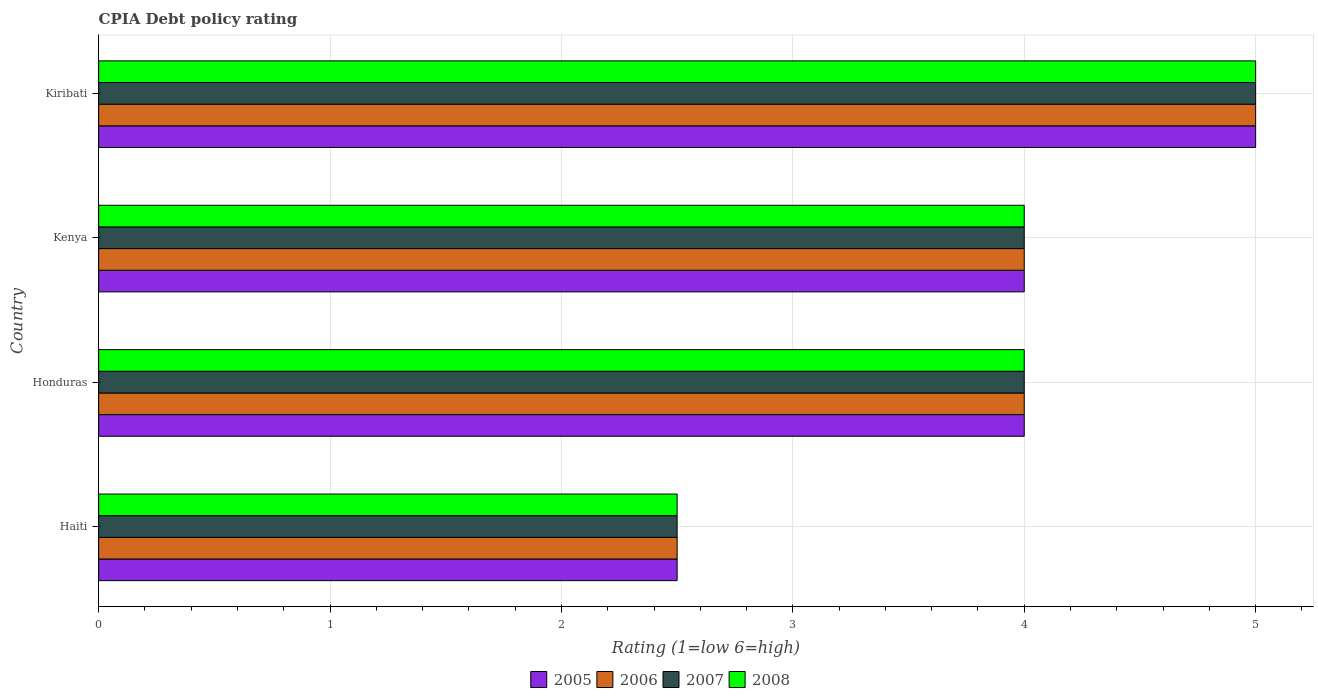How many groups of bars are there?
Offer a terse response. 4. Are the number of bars on each tick of the Y-axis equal?
Keep it short and to the point. Yes. How many bars are there on the 4th tick from the bottom?
Keep it short and to the point. 4. What is the label of the 4th group of bars from the top?
Your response must be concise. Haiti. In how many cases, is the number of bars for a given country not equal to the number of legend labels?
Make the answer very short. 0. What is the CPIA rating in 2008 in Kiribati?
Keep it short and to the point. 5. Across all countries, what is the maximum CPIA rating in 2006?
Offer a very short reply. 5. In which country was the CPIA rating in 2007 maximum?
Your answer should be very brief. Kiribati. In which country was the CPIA rating in 2007 minimum?
Offer a terse response. Haiti. What is the total CPIA rating in 2007 in the graph?
Provide a short and direct response. 15.5. What is the average CPIA rating in 2006 per country?
Offer a terse response. 3.88. What is the difference between the CPIA rating in 2006 and CPIA rating in 2008 in Honduras?
Your answer should be compact. 0. Is the CPIA rating in 2006 in Haiti less than that in Kenya?
Ensure brevity in your answer.  Yes. What is the difference between the highest and the second highest CPIA rating in 2005?
Offer a terse response. 1. Is the sum of the CPIA rating in 2008 in Haiti and Honduras greater than the maximum CPIA rating in 2005 across all countries?
Ensure brevity in your answer.  Yes. What does the 1st bar from the top in Haiti represents?
Your answer should be compact. 2008. Are all the bars in the graph horizontal?
Make the answer very short. Yes. How many countries are there in the graph?
Offer a terse response. 4. What is the difference between two consecutive major ticks on the X-axis?
Ensure brevity in your answer.  1. Are the values on the major ticks of X-axis written in scientific E-notation?
Provide a succinct answer. No. Does the graph contain any zero values?
Keep it short and to the point. No. Where does the legend appear in the graph?
Your answer should be compact. Bottom center. What is the title of the graph?
Give a very brief answer. CPIA Debt policy rating. Does "2006" appear as one of the legend labels in the graph?
Your answer should be compact. Yes. What is the label or title of the X-axis?
Keep it short and to the point. Rating (1=low 6=high). What is the label or title of the Y-axis?
Offer a very short reply. Country. What is the Rating (1=low 6=high) of 2006 in Haiti?
Make the answer very short. 2.5. What is the Rating (1=low 6=high) of 2007 in Haiti?
Your answer should be very brief. 2.5. What is the Rating (1=low 6=high) of 2005 in Honduras?
Provide a succinct answer. 4. What is the Rating (1=low 6=high) of 2008 in Honduras?
Your response must be concise. 4. What is the Rating (1=low 6=high) of 2005 in Kenya?
Provide a succinct answer. 4. What is the Rating (1=low 6=high) of 2007 in Kenya?
Keep it short and to the point. 4. What is the Rating (1=low 6=high) in 2008 in Kenya?
Offer a very short reply. 4. What is the Rating (1=low 6=high) in 2007 in Kiribati?
Provide a short and direct response. 5. What is the Rating (1=low 6=high) of 2008 in Kiribati?
Make the answer very short. 5. Across all countries, what is the maximum Rating (1=low 6=high) of 2005?
Provide a succinct answer. 5. Across all countries, what is the maximum Rating (1=low 6=high) in 2006?
Ensure brevity in your answer.  5. Across all countries, what is the minimum Rating (1=low 6=high) in 2007?
Provide a short and direct response. 2.5. Across all countries, what is the minimum Rating (1=low 6=high) of 2008?
Your answer should be very brief. 2.5. What is the total Rating (1=low 6=high) in 2007 in the graph?
Give a very brief answer. 15.5. What is the difference between the Rating (1=low 6=high) in 2005 in Haiti and that in Kenya?
Offer a very short reply. -1.5. What is the difference between the Rating (1=low 6=high) in 2008 in Haiti and that in Kenya?
Provide a succinct answer. -1.5. What is the difference between the Rating (1=low 6=high) of 2005 in Haiti and that in Kiribati?
Ensure brevity in your answer.  -2.5. What is the difference between the Rating (1=low 6=high) of 2006 in Haiti and that in Kiribati?
Ensure brevity in your answer.  -2.5. What is the difference between the Rating (1=low 6=high) of 2008 in Haiti and that in Kiribati?
Give a very brief answer. -2.5. What is the difference between the Rating (1=low 6=high) in 2005 in Honduras and that in Kenya?
Provide a succinct answer. 0. What is the difference between the Rating (1=low 6=high) in 2006 in Honduras and that in Kenya?
Your response must be concise. 0. What is the difference between the Rating (1=low 6=high) of 2005 in Honduras and that in Kiribati?
Provide a succinct answer. -1. What is the difference between the Rating (1=low 6=high) of 2008 in Honduras and that in Kiribati?
Give a very brief answer. -1. What is the difference between the Rating (1=low 6=high) of 2006 in Kenya and that in Kiribati?
Give a very brief answer. -1. What is the difference between the Rating (1=low 6=high) of 2007 in Kenya and that in Kiribati?
Ensure brevity in your answer.  -1. What is the difference between the Rating (1=low 6=high) in 2008 in Kenya and that in Kiribati?
Provide a succinct answer. -1. What is the difference between the Rating (1=low 6=high) of 2005 in Haiti and the Rating (1=low 6=high) of 2008 in Honduras?
Provide a succinct answer. -1.5. What is the difference between the Rating (1=low 6=high) of 2006 in Haiti and the Rating (1=low 6=high) of 2007 in Honduras?
Offer a terse response. -1.5. What is the difference between the Rating (1=low 6=high) of 2005 in Haiti and the Rating (1=low 6=high) of 2007 in Kenya?
Offer a terse response. -1.5. What is the difference between the Rating (1=low 6=high) of 2006 in Haiti and the Rating (1=low 6=high) of 2008 in Kenya?
Your response must be concise. -1.5. What is the difference between the Rating (1=low 6=high) in 2007 in Haiti and the Rating (1=low 6=high) in 2008 in Kenya?
Ensure brevity in your answer.  -1.5. What is the difference between the Rating (1=low 6=high) in 2005 in Haiti and the Rating (1=low 6=high) in 2006 in Kiribati?
Provide a succinct answer. -2.5. What is the difference between the Rating (1=low 6=high) of 2006 in Haiti and the Rating (1=low 6=high) of 2008 in Kiribati?
Offer a very short reply. -2.5. What is the difference between the Rating (1=low 6=high) in 2007 in Haiti and the Rating (1=low 6=high) in 2008 in Kiribati?
Ensure brevity in your answer.  -2.5. What is the difference between the Rating (1=low 6=high) of 2005 in Honduras and the Rating (1=low 6=high) of 2008 in Kenya?
Offer a very short reply. 0. What is the difference between the Rating (1=low 6=high) in 2005 in Honduras and the Rating (1=low 6=high) in 2006 in Kiribati?
Offer a terse response. -1. What is the difference between the Rating (1=low 6=high) in 2005 in Honduras and the Rating (1=low 6=high) in 2007 in Kiribati?
Offer a terse response. -1. What is the difference between the Rating (1=low 6=high) in 2005 in Honduras and the Rating (1=low 6=high) in 2008 in Kiribati?
Provide a short and direct response. -1. What is the difference between the Rating (1=low 6=high) in 2007 in Honduras and the Rating (1=low 6=high) in 2008 in Kiribati?
Your response must be concise. -1. What is the difference between the Rating (1=low 6=high) of 2005 in Kenya and the Rating (1=low 6=high) of 2006 in Kiribati?
Keep it short and to the point. -1. What is the difference between the Rating (1=low 6=high) in 2005 in Kenya and the Rating (1=low 6=high) in 2008 in Kiribati?
Give a very brief answer. -1. What is the difference between the Rating (1=low 6=high) of 2006 in Kenya and the Rating (1=low 6=high) of 2008 in Kiribati?
Your answer should be very brief. -1. What is the difference between the Rating (1=low 6=high) of 2007 in Kenya and the Rating (1=low 6=high) of 2008 in Kiribati?
Provide a short and direct response. -1. What is the average Rating (1=low 6=high) of 2005 per country?
Offer a very short reply. 3.88. What is the average Rating (1=low 6=high) of 2006 per country?
Offer a terse response. 3.88. What is the average Rating (1=low 6=high) in 2007 per country?
Ensure brevity in your answer.  3.88. What is the average Rating (1=low 6=high) in 2008 per country?
Provide a succinct answer. 3.88. What is the difference between the Rating (1=low 6=high) of 2005 and Rating (1=low 6=high) of 2006 in Haiti?
Make the answer very short. 0. What is the difference between the Rating (1=low 6=high) of 2007 and Rating (1=low 6=high) of 2008 in Haiti?
Ensure brevity in your answer.  0. What is the difference between the Rating (1=low 6=high) in 2005 and Rating (1=low 6=high) in 2006 in Honduras?
Keep it short and to the point. 0. What is the difference between the Rating (1=low 6=high) of 2005 and Rating (1=low 6=high) of 2008 in Honduras?
Ensure brevity in your answer.  0. What is the difference between the Rating (1=low 6=high) of 2006 and Rating (1=low 6=high) of 2007 in Honduras?
Offer a terse response. 0. What is the difference between the Rating (1=low 6=high) in 2006 and Rating (1=low 6=high) in 2008 in Honduras?
Offer a terse response. 0. What is the difference between the Rating (1=low 6=high) of 2007 and Rating (1=low 6=high) of 2008 in Honduras?
Offer a very short reply. 0. What is the difference between the Rating (1=low 6=high) of 2005 and Rating (1=low 6=high) of 2006 in Kenya?
Your answer should be very brief. 0. What is the difference between the Rating (1=low 6=high) of 2005 and Rating (1=low 6=high) of 2006 in Kiribati?
Provide a succinct answer. 0. What is the difference between the Rating (1=low 6=high) of 2005 and Rating (1=low 6=high) of 2008 in Kiribati?
Offer a terse response. 0. What is the difference between the Rating (1=low 6=high) in 2006 and Rating (1=low 6=high) in 2008 in Kiribati?
Your answer should be very brief. 0. What is the difference between the Rating (1=low 6=high) in 2007 and Rating (1=low 6=high) in 2008 in Kiribati?
Give a very brief answer. 0. What is the ratio of the Rating (1=low 6=high) in 2005 in Haiti to that in Honduras?
Keep it short and to the point. 0.62. What is the ratio of the Rating (1=low 6=high) of 2006 in Haiti to that in Honduras?
Provide a succinct answer. 0.62. What is the ratio of the Rating (1=low 6=high) in 2008 in Haiti to that in Kenya?
Give a very brief answer. 0.62. What is the ratio of the Rating (1=low 6=high) in 2005 in Haiti to that in Kiribati?
Ensure brevity in your answer.  0.5. What is the ratio of the Rating (1=low 6=high) in 2006 in Haiti to that in Kiribati?
Give a very brief answer. 0.5. What is the ratio of the Rating (1=low 6=high) in 2006 in Honduras to that in Kenya?
Ensure brevity in your answer.  1. What is the ratio of the Rating (1=low 6=high) in 2007 in Honduras to that in Kenya?
Provide a short and direct response. 1. What is the ratio of the Rating (1=low 6=high) of 2005 in Honduras to that in Kiribati?
Your answer should be very brief. 0.8. What is the ratio of the Rating (1=low 6=high) of 2006 in Honduras to that in Kiribati?
Offer a terse response. 0.8. What is the ratio of the Rating (1=low 6=high) in 2007 in Honduras to that in Kiribati?
Your response must be concise. 0.8. What is the ratio of the Rating (1=low 6=high) in 2007 in Kenya to that in Kiribati?
Offer a terse response. 0.8. What is the ratio of the Rating (1=low 6=high) of 2008 in Kenya to that in Kiribati?
Your answer should be very brief. 0.8. What is the difference between the highest and the second highest Rating (1=low 6=high) in 2006?
Offer a terse response. 1. What is the difference between the highest and the second highest Rating (1=low 6=high) of 2007?
Give a very brief answer. 1. What is the difference between the highest and the lowest Rating (1=low 6=high) in 2005?
Your response must be concise. 2.5. What is the difference between the highest and the lowest Rating (1=low 6=high) in 2006?
Your answer should be very brief. 2.5. What is the difference between the highest and the lowest Rating (1=low 6=high) of 2007?
Your response must be concise. 2.5. 